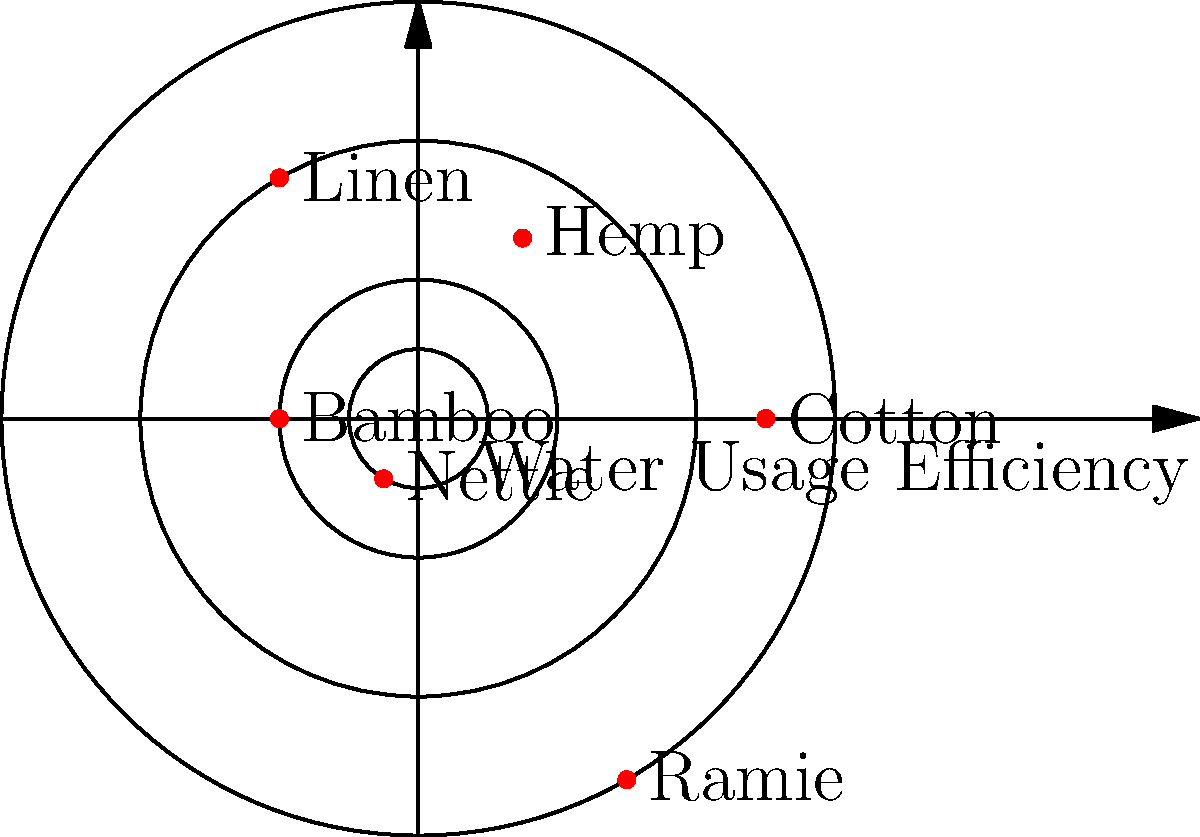The polar scatter plot shows the water usage efficiency of different natural textile production methods. Higher values indicate less efficient water usage (more water consumed). Based on this information, which natural textile production method appears to be the most water-efficient? To determine the most water-efficient textile production method, we need to analyze the polar scatter plot:

1. The distance from the center represents water usage efficiency, with higher values indicating less efficiency (more water consumed).
2. We need to identify the point closest to the center, as it represents the most water-efficient method.

Let's examine each textile:

1. Cotton: positioned at about 5 units from the center
2. Hemp: positioned at about 3 units from the center
3. Linen: positioned at about 4 units from the center
4. Bamboo: positioned at about 2 units from the center
5. Nettle: positioned at about 1 unit from the center
6. Ramie: positioned at about 6 units from the center

Comparing these values, we can see that Nettle is closest to the center at approximately 1 unit. This indicates that Nettle production has the highest water usage efficiency among the textiles shown.
Answer: Nettle 